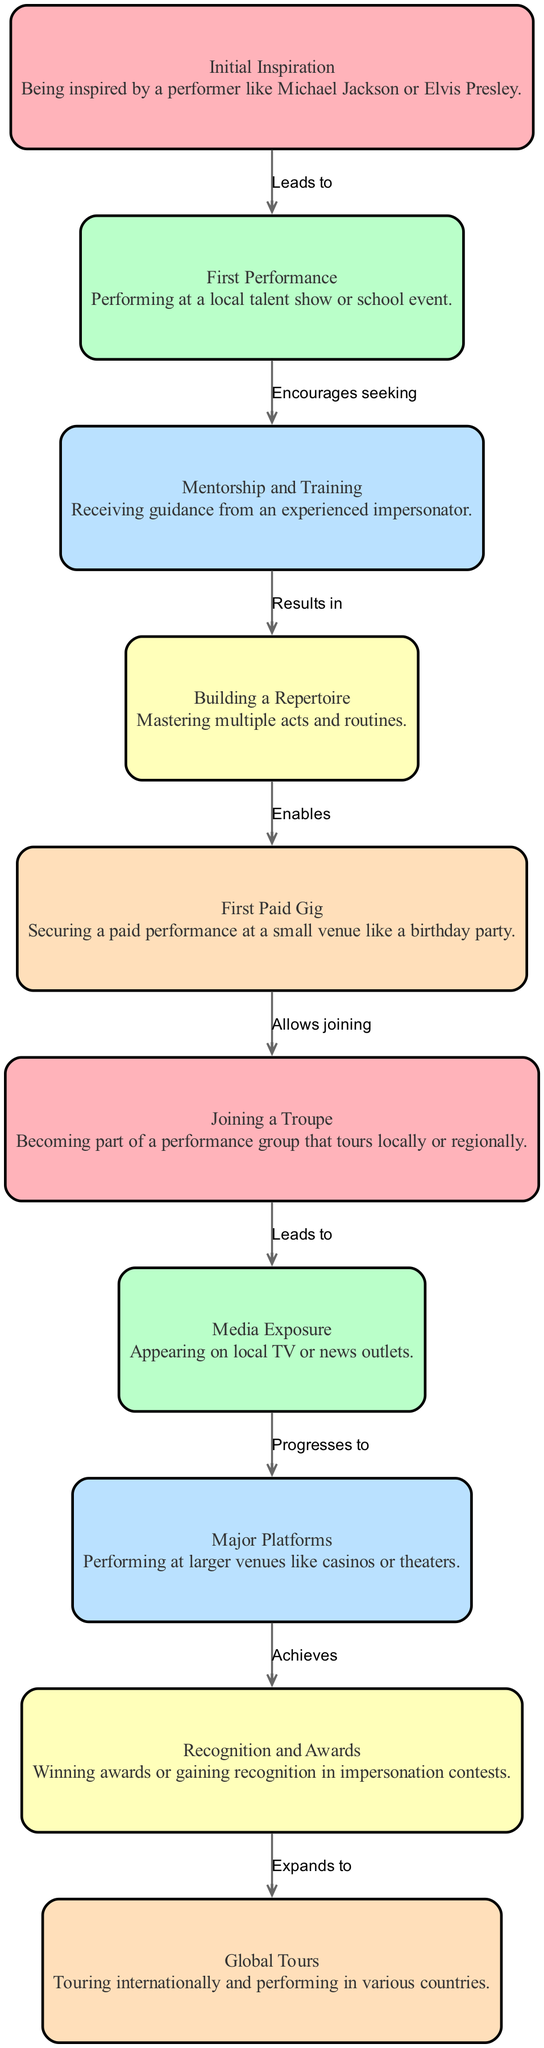What is the first key moment in the journey of self-confidence? The first key moment listed in the diagram is "Initial Inspiration," which indicates being inspired by a performer.
Answer: Initial Inspiration How many total nodes are in the diagram? The diagram lists ten nodes detailing the journey, from initial inspiration to global tours.
Answer: 10 What does the "First Performance" lead to? According to the diagram, the "First Performance" encourages seeking mentorship and training from experienced impersonators.
Answer: Encourages seeking What does "Media Exposure" progress to? The diagram shows that "Media Exposure" progresses to performing on major platforms, such as casinos or theaters.
Answer: Progresses to What type of performance is the "First Paid Gig"? The diagram classifies the "First Paid Gig" as a securing performance at a small venue like a birthday party.
Answer: Small venue What result is achieved when one reaches "Recognition and Awards"? Reaching "Recognition and Awards" achieves recognition in impersonation contests and winning awards.
Answer: Achieves What is the relationship between "Joining a Troupe" and "Media Exposure"? The relationship indicates that joining a troupe leads to media exposure, enhancing the impersonator's visibility.
Answer: Leads to Which performance marks a significant expansion in the impersonator's career? The "Global Tours" section signifies a major expansion, indicating international performances across various countries.
Answer: Global Tours What occurs after mastering multiple acts and routines? After mastering acts, it enables the impersonator to secure their first paid gig, marking an important milestone.
Answer: Enables 